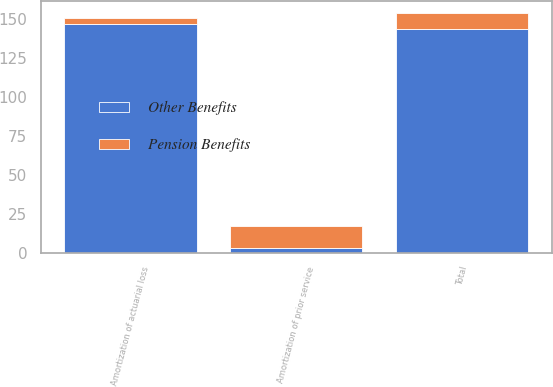<chart> <loc_0><loc_0><loc_500><loc_500><stacked_bar_chart><ecel><fcel>Amortization of prior service<fcel>Amortization of actuarial loss<fcel>Total<nl><fcel>Other Benefits<fcel>3<fcel>147<fcel>144<nl><fcel>Pension Benefits<fcel>14<fcel>4<fcel>10<nl></chart> 